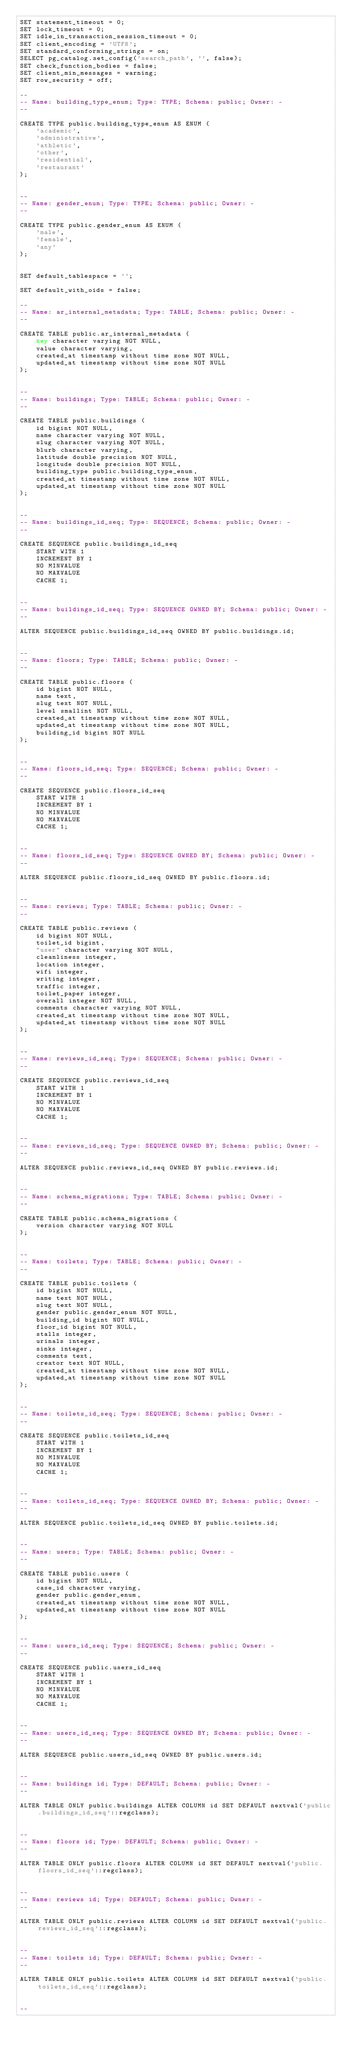<code> <loc_0><loc_0><loc_500><loc_500><_SQL_>SET statement_timeout = 0;
SET lock_timeout = 0;
SET idle_in_transaction_session_timeout = 0;
SET client_encoding = 'UTF8';
SET standard_conforming_strings = on;
SELECT pg_catalog.set_config('search_path', '', false);
SET check_function_bodies = false;
SET client_min_messages = warning;
SET row_security = off;

--
-- Name: building_type_enum; Type: TYPE; Schema: public; Owner: -
--

CREATE TYPE public.building_type_enum AS ENUM (
    'academic',
    'administrative',
    'athletic',
    'other',
    'residential',
    'restaurant'
);


--
-- Name: gender_enum; Type: TYPE; Schema: public; Owner: -
--

CREATE TYPE public.gender_enum AS ENUM (
    'male',
    'female',
    'any'
);


SET default_tablespace = '';

SET default_with_oids = false;

--
-- Name: ar_internal_metadata; Type: TABLE; Schema: public; Owner: -
--

CREATE TABLE public.ar_internal_metadata (
    key character varying NOT NULL,
    value character varying,
    created_at timestamp without time zone NOT NULL,
    updated_at timestamp without time zone NOT NULL
);


--
-- Name: buildings; Type: TABLE; Schema: public; Owner: -
--

CREATE TABLE public.buildings (
    id bigint NOT NULL,
    name character varying NOT NULL,
    slug character varying NOT NULL,
    blurb character varying,
    latitude double precision NOT NULL,
    longitude double precision NOT NULL,
    building_type public.building_type_enum,
    created_at timestamp without time zone NOT NULL,
    updated_at timestamp without time zone NOT NULL
);


--
-- Name: buildings_id_seq; Type: SEQUENCE; Schema: public; Owner: -
--

CREATE SEQUENCE public.buildings_id_seq
    START WITH 1
    INCREMENT BY 1
    NO MINVALUE
    NO MAXVALUE
    CACHE 1;


--
-- Name: buildings_id_seq; Type: SEQUENCE OWNED BY; Schema: public; Owner: -
--

ALTER SEQUENCE public.buildings_id_seq OWNED BY public.buildings.id;


--
-- Name: floors; Type: TABLE; Schema: public; Owner: -
--

CREATE TABLE public.floors (
    id bigint NOT NULL,
    name text,
    slug text NOT NULL,
    level smallint NOT NULL,
    created_at timestamp without time zone NOT NULL,
    updated_at timestamp without time zone NOT NULL,
    building_id bigint NOT NULL
);


--
-- Name: floors_id_seq; Type: SEQUENCE; Schema: public; Owner: -
--

CREATE SEQUENCE public.floors_id_seq
    START WITH 1
    INCREMENT BY 1
    NO MINVALUE
    NO MAXVALUE
    CACHE 1;


--
-- Name: floors_id_seq; Type: SEQUENCE OWNED BY; Schema: public; Owner: -
--

ALTER SEQUENCE public.floors_id_seq OWNED BY public.floors.id;


--
-- Name: reviews; Type: TABLE; Schema: public; Owner: -
--

CREATE TABLE public.reviews (
    id bigint NOT NULL,
    toilet_id bigint,
    "user" character varying NOT NULL,
    cleanliness integer,
    location integer,
    wifi integer,
    writing integer,
    traffic integer,
    toilet_paper integer,
    overall integer NOT NULL,
    comments character varying NOT NULL,
    created_at timestamp without time zone NOT NULL,
    updated_at timestamp without time zone NOT NULL
);


--
-- Name: reviews_id_seq; Type: SEQUENCE; Schema: public; Owner: -
--

CREATE SEQUENCE public.reviews_id_seq
    START WITH 1
    INCREMENT BY 1
    NO MINVALUE
    NO MAXVALUE
    CACHE 1;


--
-- Name: reviews_id_seq; Type: SEQUENCE OWNED BY; Schema: public; Owner: -
--

ALTER SEQUENCE public.reviews_id_seq OWNED BY public.reviews.id;


--
-- Name: schema_migrations; Type: TABLE; Schema: public; Owner: -
--

CREATE TABLE public.schema_migrations (
    version character varying NOT NULL
);


--
-- Name: toilets; Type: TABLE; Schema: public; Owner: -
--

CREATE TABLE public.toilets (
    id bigint NOT NULL,
    name text NOT NULL,
    slug text NOT NULL,
    gender public.gender_enum NOT NULL,
    building_id bigint NOT NULL,
    floor_id bigint NOT NULL,
    stalls integer,
    urinals integer,
    sinks integer,
    comments text,
    creator text NOT NULL,
    created_at timestamp without time zone NOT NULL,
    updated_at timestamp without time zone NOT NULL
);


--
-- Name: toilets_id_seq; Type: SEQUENCE; Schema: public; Owner: -
--

CREATE SEQUENCE public.toilets_id_seq
    START WITH 1
    INCREMENT BY 1
    NO MINVALUE
    NO MAXVALUE
    CACHE 1;


--
-- Name: toilets_id_seq; Type: SEQUENCE OWNED BY; Schema: public; Owner: -
--

ALTER SEQUENCE public.toilets_id_seq OWNED BY public.toilets.id;


--
-- Name: users; Type: TABLE; Schema: public; Owner: -
--

CREATE TABLE public.users (
    id bigint NOT NULL,
    case_id character varying,
    gender public.gender_enum,
    created_at timestamp without time zone NOT NULL,
    updated_at timestamp without time zone NOT NULL
);


--
-- Name: users_id_seq; Type: SEQUENCE; Schema: public; Owner: -
--

CREATE SEQUENCE public.users_id_seq
    START WITH 1
    INCREMENT BY 1
    NO MINVALUE
    NO MAXVALUE
    CACHE 1;


--
-- Name: users_id_seq; Type: SEQUENCE OWNED BY; Schema: public; Owner: -
--

ALTER SEQUENCE public.users_id_seq OWNED BY public.users.id;


--
-- Name: buildings id; Type: DEFAULT; Schema: public; Owner: -
--

ALTER TABLE ONLY public.buildings ALTER COLUMN id SET DEFAULT nextval('public.buildings_id_seq'::regclass);


--
-- Name: floors id; Type: DEFAULT; Schema: public; Owner: -
--

ALTER TABLE ONLY public.floors ALTER COLUMN id SET DEFAULT nextval('public.floors_id_seq'::regclass);


--
-- Name: reviews id; Type: DEFAULT; Schema: public; Owner: -
--

ALTER TABLE ONLY public.reviews ALTER COLUMN id SET DEFAULT nextval('public.reviews_id_seq'::regclass);


--
-- Name: toilets id; Type: DEFAULT; Schema: public; Owner: -
--

ALTER TABLE ONLY public.toilets ALTER COLUMN id SET DEFAULT nextval('public.toilets_id_seq'::regclass);


--</code> 